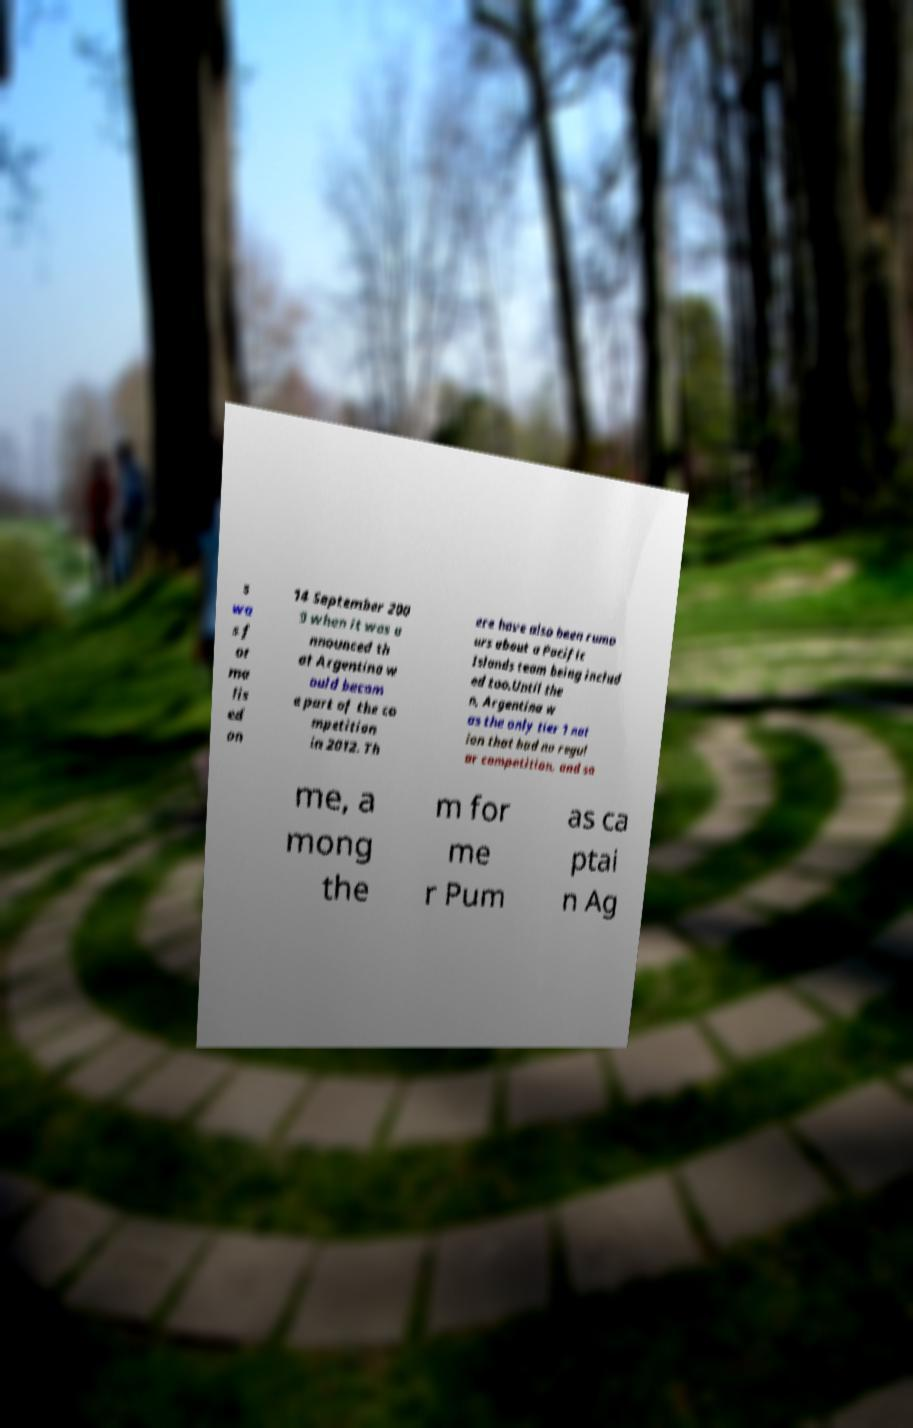What messages or text are displayed in this image? I need them in a readable, typed format. s wa s f or ma lis ed on 14 September 200 9 when it was a nnounced th at Argentina w ould becom e part of the co mpetition in 2012. Th ere have also been rumo urs about a Pacific Islands team being includ ed too.Until the n, Argentina w as the only tier 1 nat ion that had no regul ar competition, and so me, a mong the m for me r Pum as ca ptai n Ag 